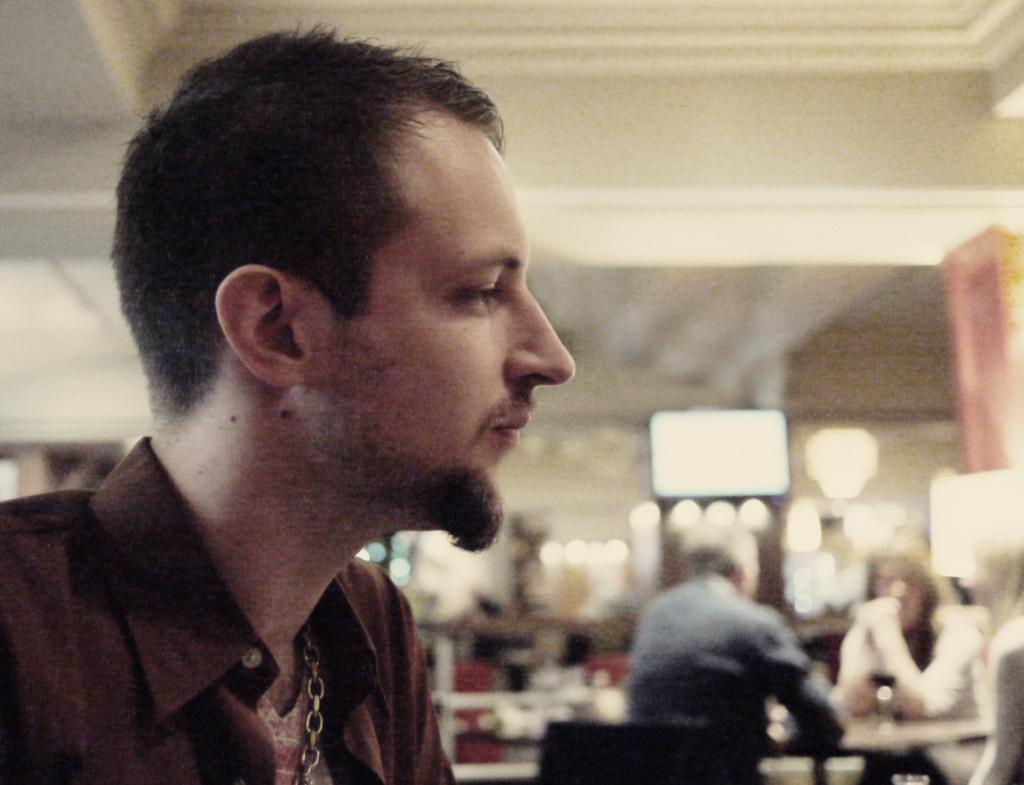Who is present in the image? There is a man in the image. What can be seen in the background of the image? In the background of the image, there are walls, pillars, persons sitting on chairs, and electric lights. What page of the book is the man reading in the image? There is no book present in the image, so it is not possible to determine which page the man might be reading. 